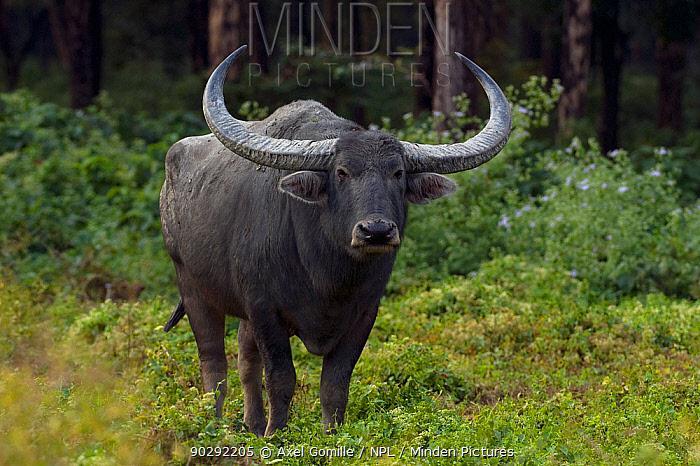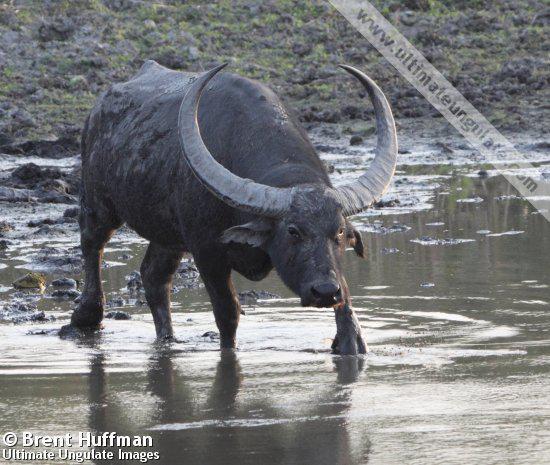The first image is the image on the left, the second image is the image on the right. Considering the images on both sides, is "In one image there is a lone water buffalo standing in water." valid? Answer yes or no. Yes. 